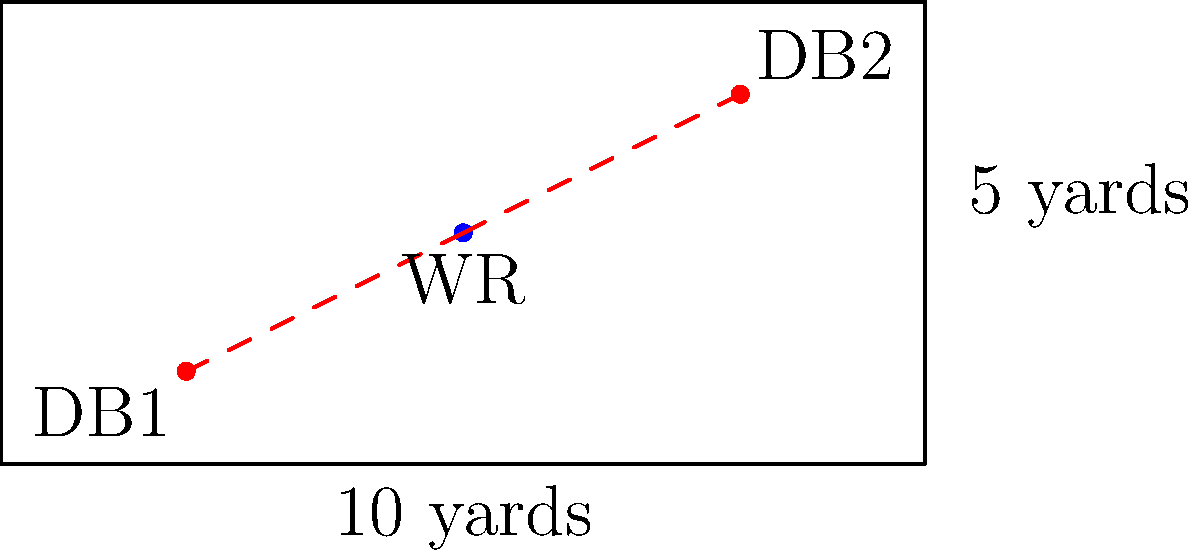As a wide receiver, you're analyzing the area you need to cover in the end zone against two defensive backs (DBs). The end zone is 10 yards wide and 5 yards deep. DB1 is positioned at (2,1) and DB2 at (8,4) in a yard-based coordinate system. Assuming you're at position (5,2.5), what is the area of the triangle formed by you and the two DBs? Express your answer in square yards. To solve this problem, we'll use the following steps:

1) First, we need to identify the coordinates of the three points forming the triangle:
   WR: (5, 2.5)
   DB1: (2, 1)
   DB2: (8, 4)

2) We can use the formula for the area of a triangle given three points:
   Area = $\frac{1}{2}|x_1(y_2 - y_3) + x_2(y_3 - y_1) + x_3(y_1 - y_2)|$

   Where $(x_1, y_1)$, $(x_2, y_2)$, and $(x_3, y_3)$ are the coordinates of the three points.

3) Let's substitute our values into the formula:
   Area = $\frac{1}{2}|5(1 - 4) + 2(4 - 2.5) + 8(2.5 - 1)|$

4) Simplify inside the parentheses:
   Area = $\frac{1}{2}|5(-3) + 2(1.5) + 8(1.5)|$

5) Multiply:
   Area = $\frac{1}{2}|-15 + 3 + 12|$

6) Add inside the absolute value signs:
   Area = $\frac{1}{2}|0|$

7) Simplify:
   Area = 0 square yards
Answer: 0 square yards 